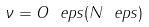<formula> <loc_0><loc_0><loc_500><loc_500>\nu = O _ { \ } e p s ( N ^ { \ } e p s )</formula> 